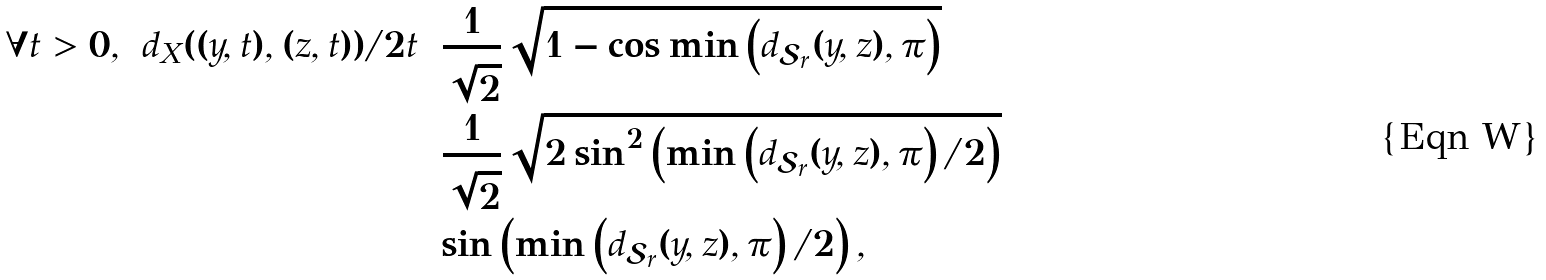<formula> <loc_0><loc_0><loc_500><loc_500>\forall t > 0 , \ d _ { X } ( ( y , t ) , ( z , t ) ) / 2 t & = \frac { 1 } { \sqrt { 2 } } \sqrt { 1 - \cos \min \left ( d _ { \mathcal { S } _ { r } } ( y , z ) , \pi \right ) } \\ & = \frac { 1 } { \sqrt { 2 } } \sqrt { 2 \sin ^ { 2 } \left ( \min \left ( d _ { \mathcal { S } _ { r } } ( y , z ) , \pi \right ) / 2 \right ) } \\ & = \sin \left ( \min \left ( d _ { \mathcal { S } _ { r } } ( y , z ) , \pi \right ) / 2 \right ) ,</formula> 